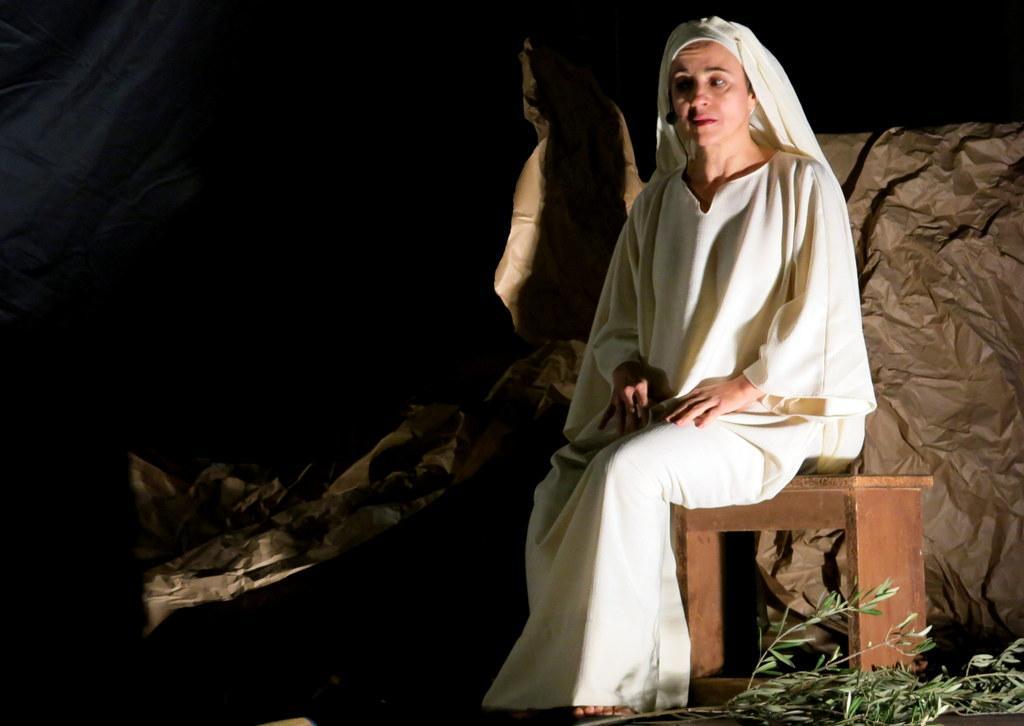Can you describe this image briefly? In this image we can see a woman is sitting on a stool. At the bottom we can see branches of a plant. In the background the image is dark but we can see objects. 